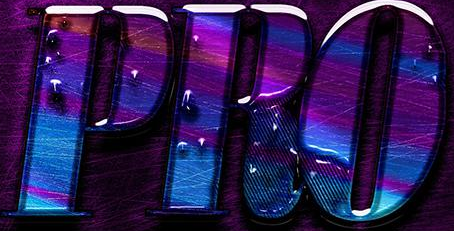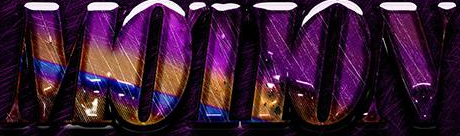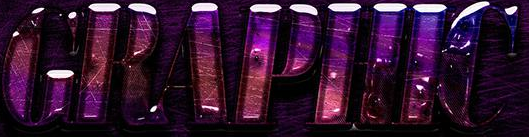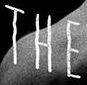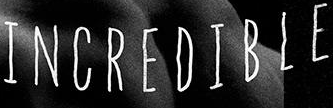What text is displayed in these images sequentially, separated by a semicolon? PRO; MOTION; GRAPHIC; THE; INCREDIBLE 